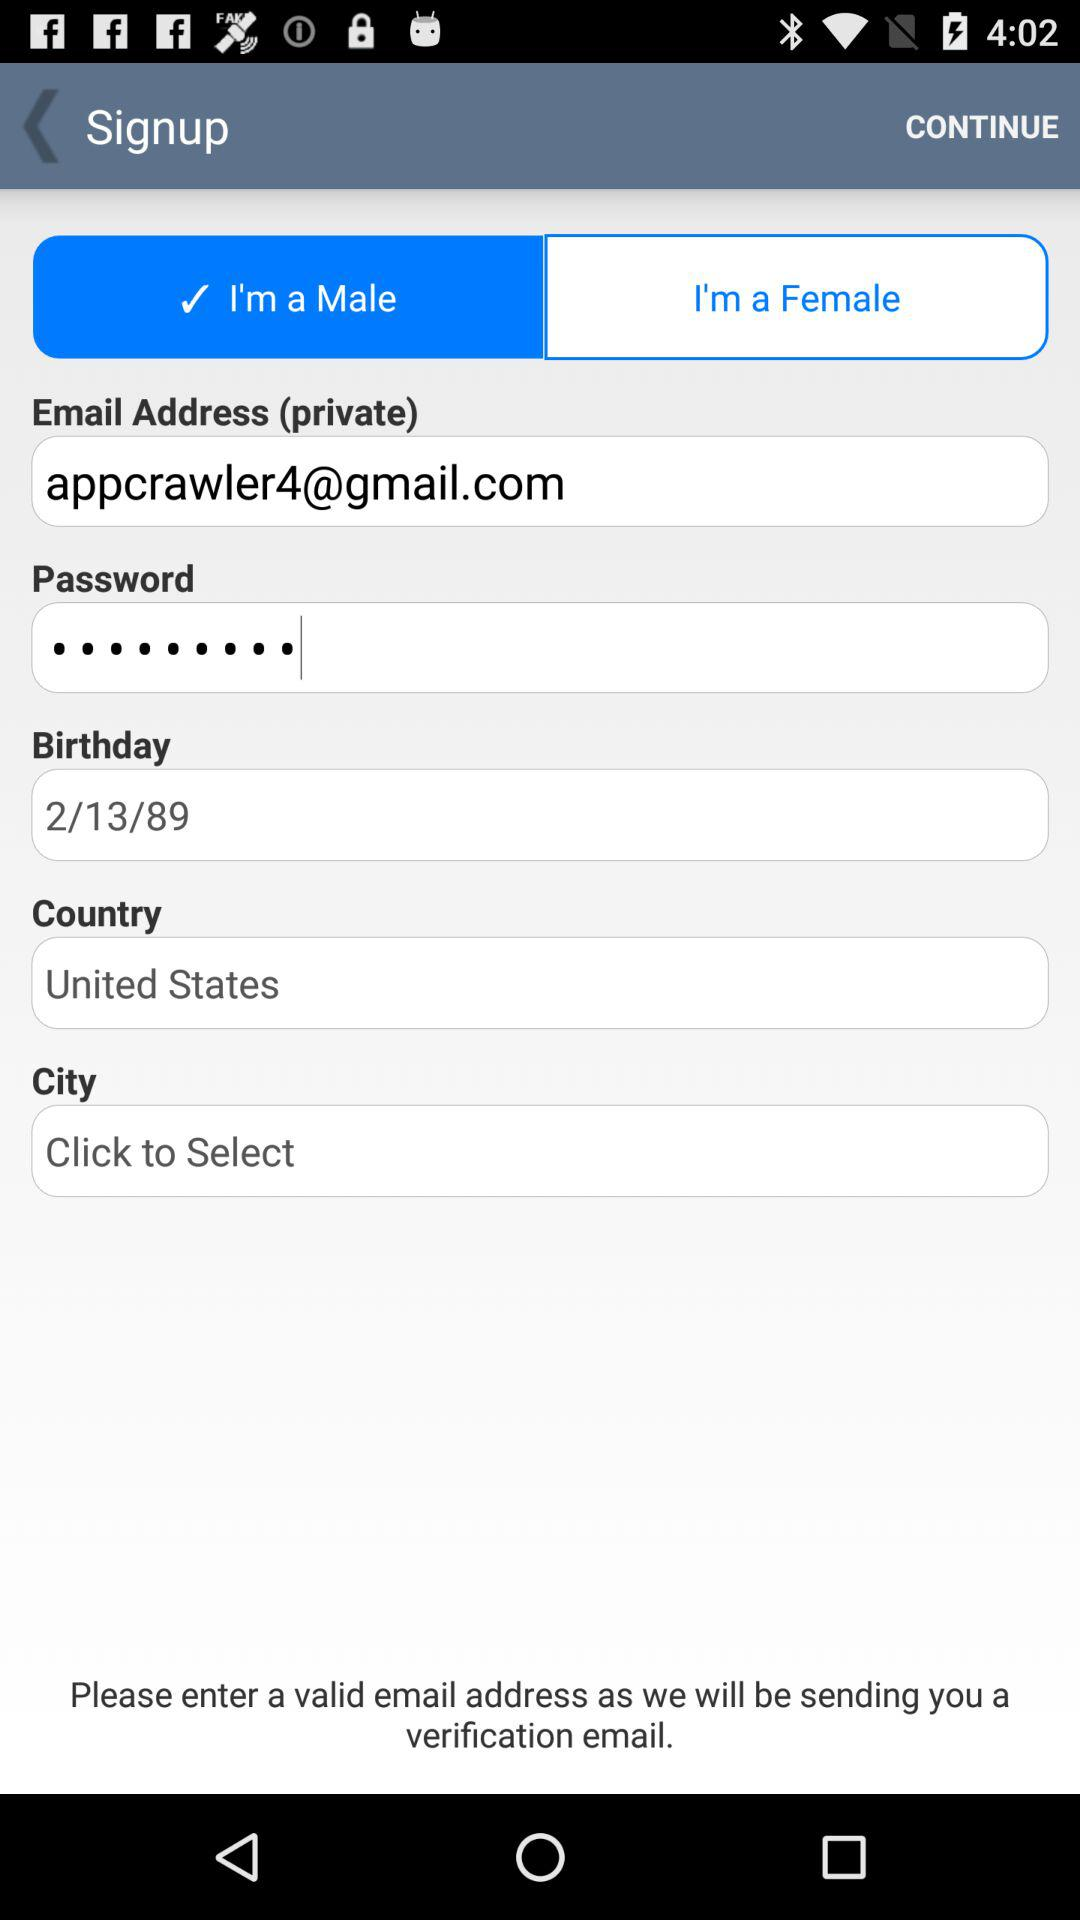Which city has been selected?
When the provided information is insufficient, respond with <no answer>. <no answer> 